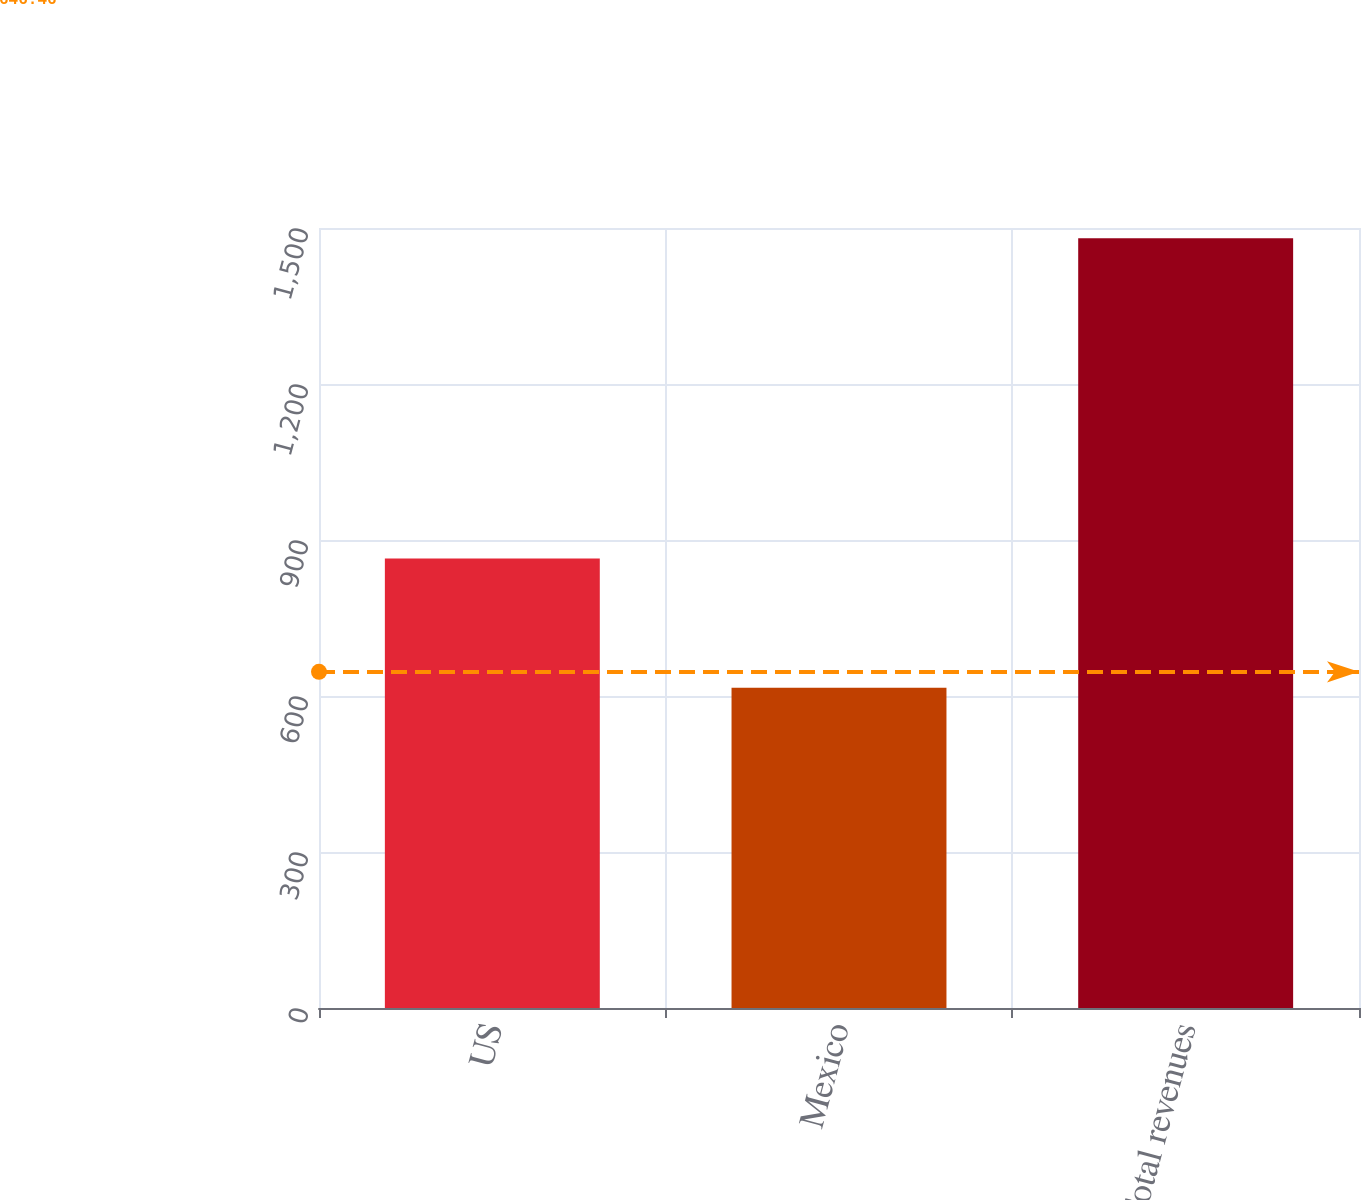<chart> <loc_0><loc_0><loc_500><loc_500><bar_chart><fcel>US<fcel>Mexico<fcel>Total revenues<nl><fcel>864.2<fcel>616<fcel>1480.2<nl></chart> 